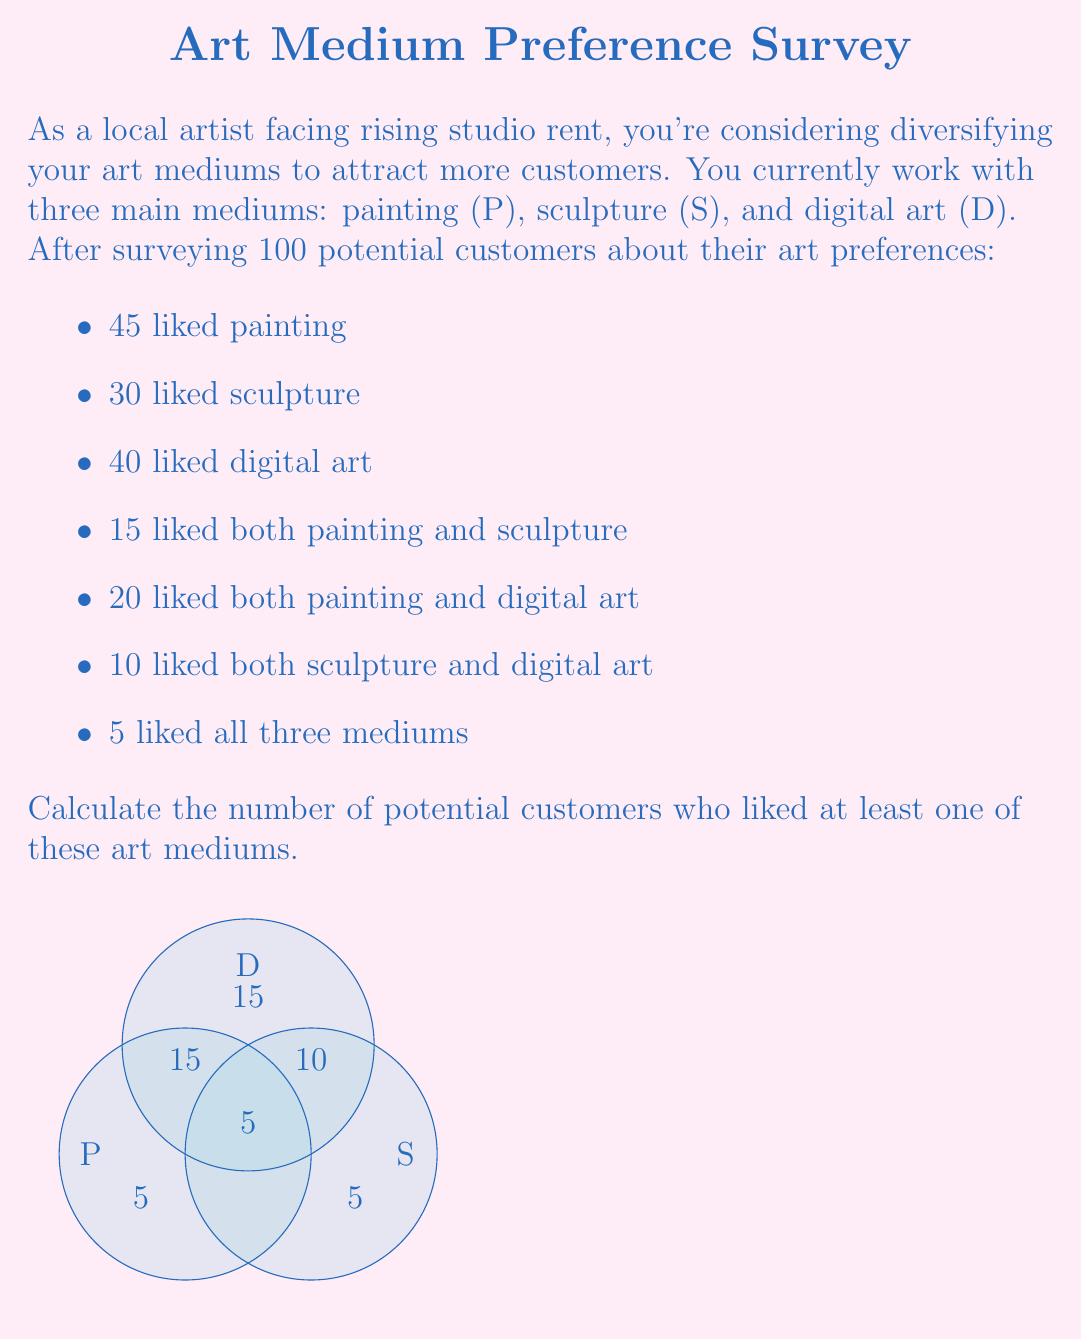Help me with this question. Let's approach this step-by-step using set theory:

1) First, we need to understand what the question is asking. We're looking for the union of all three sets: $P \cup S \cup D$.

2) We can use the inclusion-exclusion principle for three sets:

   $$|P \cup S \cup D| = |P| + |S| + |D| - |P \cap S| - |P \cap D| - |S \cap D| + |P \cap S \cap D|$$

3) We know:
   $|P| = 45$, $|S| = 30$, $|D| = 40$
   $|P \cap S| = 15$, $|P \cap D| = 20$, $|S \cap D| = 10$
   $|P \cap S \cap D| = 5$

4) Let's substitute these values into our equation:

   $$|P \cup S \cup D| = 45 + 30 + 40 - 15 - 20 - 10 + 5$$

5) Now we can calculate:

   $$|P \cup S \cup D| = 115 - 45 + 5 = 75$$

Therefore, 75 potential customers liked at least one of these art mediums.
Answer: 75 